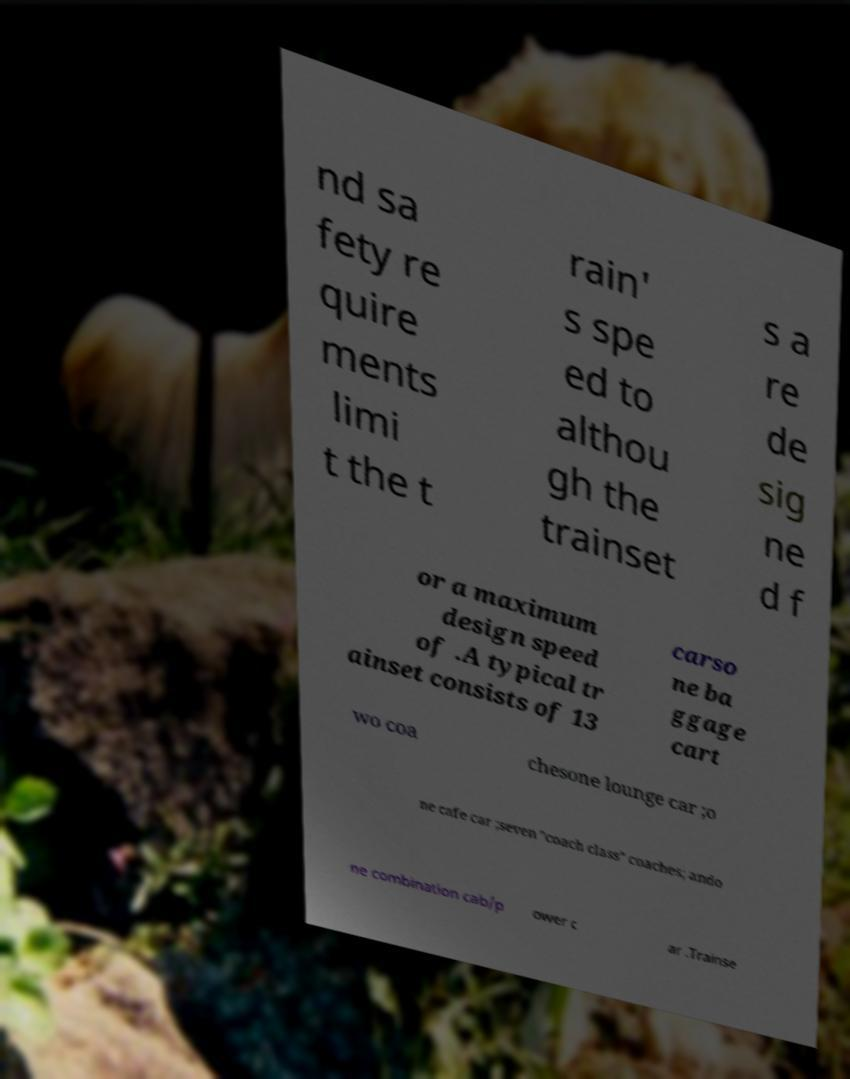Could you assist in decoding the text presented in this image and type it out clearly? nd sa fety re quire ments limi t the t rain' s spe ed to althou gh the trainset s a re de sig ne d f or a maximum design speed of .A typical tr ainset consists of 13 carso ne ba ggage cart wo coa chesone lounge car ;o ne cafe car ;seven "coach class" coaches; ando ne combination cab/p ower c ar .Trainse 